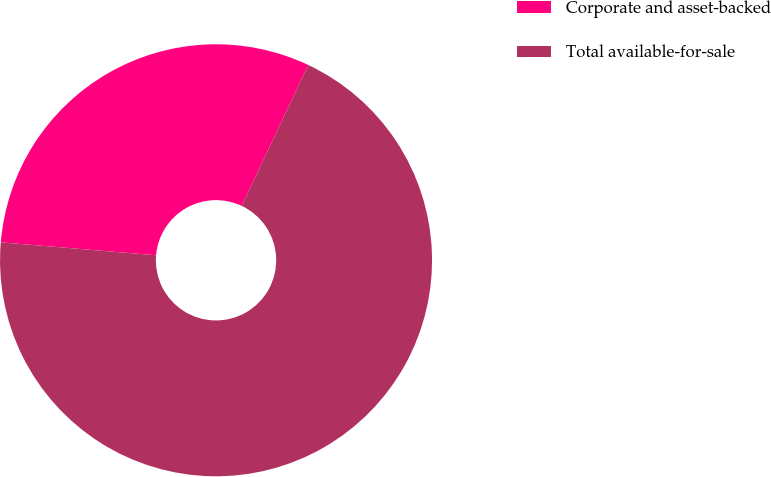<chart> <loc_0><loc_0><loc_500><loc_500><pie_chart><fcel>Corporate and asset-backed<fcel>Total available-for-sale<nl><fcel>30.7%<fcel>69.3%<nl></chart> 